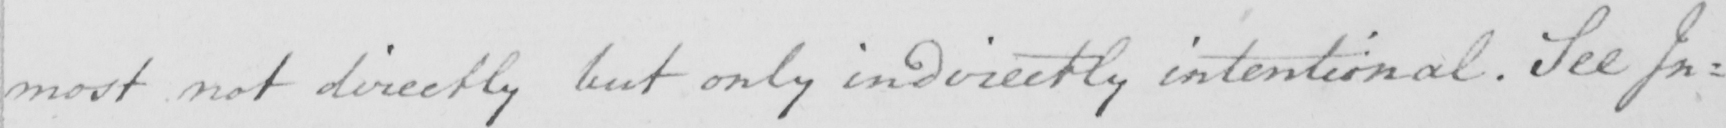What does this handwritten line say? most not directly but only indirectly intentional . See In= 